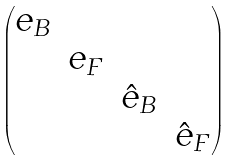<formula> <loc_0><loc_0><loc_500><loc_500>\begin{pmatrix} e _ { B } & & & \\ & e _ { F } & & \\ & & \hat { e } _ { B } & \\ & & & \hat { e } _ { F } \end{pmatrix}</formula> 